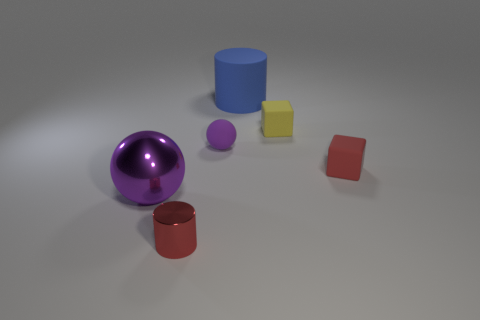Add 2 tiny cylinders. How many objects exist? 8 Subtract all cylinders. How many objects are left? 4 Add 6 tiny objects. How many tiny objects exist? 10 Subtract 0 yellow balls. How many objects are left? 6 Subtract all metal cylinders. Subtract all red metallic things. How many objects are left? 4 Add 5 large purple spheres. How many large purple spheres are left? 6 